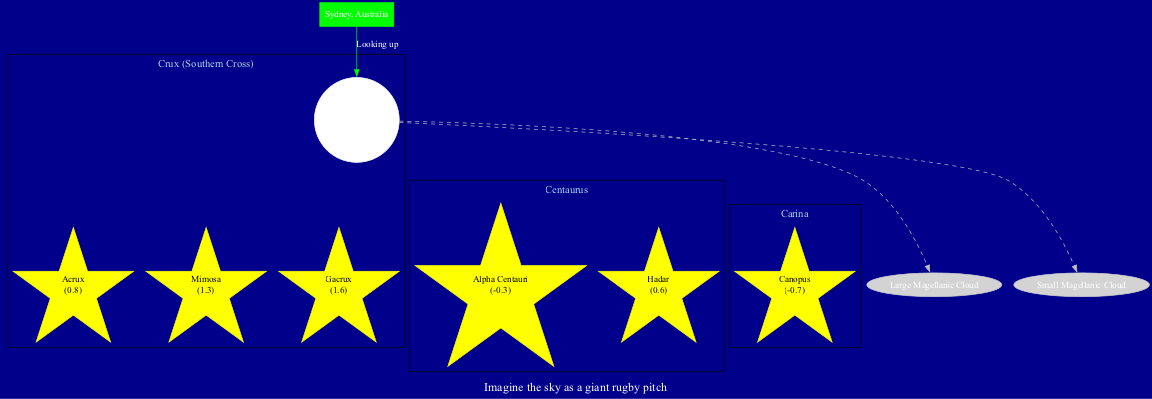What is the brightest star in the Crux constellation? The diagram lists the stars in the Crux constellation along with their magnitudes. Acrux has a magnitude of 0.8, which is lower than the other stars in the constellation, indicating it is the brightest.
Answer: Acrux How many stars are there in the Centaurus constellation? The Centaurus constellation is depicted in the diagram with two stars listed: Alpha Centauri and Hadar. Therefore, the number of stars in Centaurus is 2.
Answer: 2 What is the magnitude of Canopus? The Carina constellation is shown to have one star, Canopus, which is indicated with a magnitude of -0.7. This means Canopus is very bright and is the brightest star in its constellation.
Answer: -0.7 Which celestial object in the diagram is associated with the term 'Cloud'? The diagram lists two celestial objects: Large Magellanic Cloud and Small Magellanic Cloud. Both contain the word 'Cloud' in their names. Therefore, either could be the answer depending on the context.
Answer: Large Magellanic Cloud or Small Magellanic Cloud What star has the lowest magnitude in the whole diagram? To find the star with the lowest magnitude, we review the magnitudes of all stars listed. The magnitudes are: Acrux (0.8), Mimosa (1.3), Gacrux (1.6), Alpha Centauri (-0.3), Hadar (0.6), and Canopus (-0.7). The lowest magnitude present is -0.7 from Canopus.
Answer: Canopus How is the observer location represented in the diagram? The observer location, which is Sydney, Australia, is represented in the diagram as a green box, indicating that it’s a focal point for viewing the constellations above. It connects to the central node labeled 'Southern Sky' with an edge stating 'Looking up'.
Answer: Sydney, Australia Which constellation has three stars listed? The diagram shows the Crux constellation with three stars: Acrux, Mimosa, and Gacrux. Therefore, Crux is the constellation that has three stars listed.
Answer: Crux (Southern Cross) What is the visual representation style of the stars in the diagram? The stars in the diagram are represented as yellow star shapes, with varying sizes corresponding to their brightness (magnitude). This stylistic choice helps differentiate between the stars based on their brightness visually.
Answer: Star shapes in yellow 